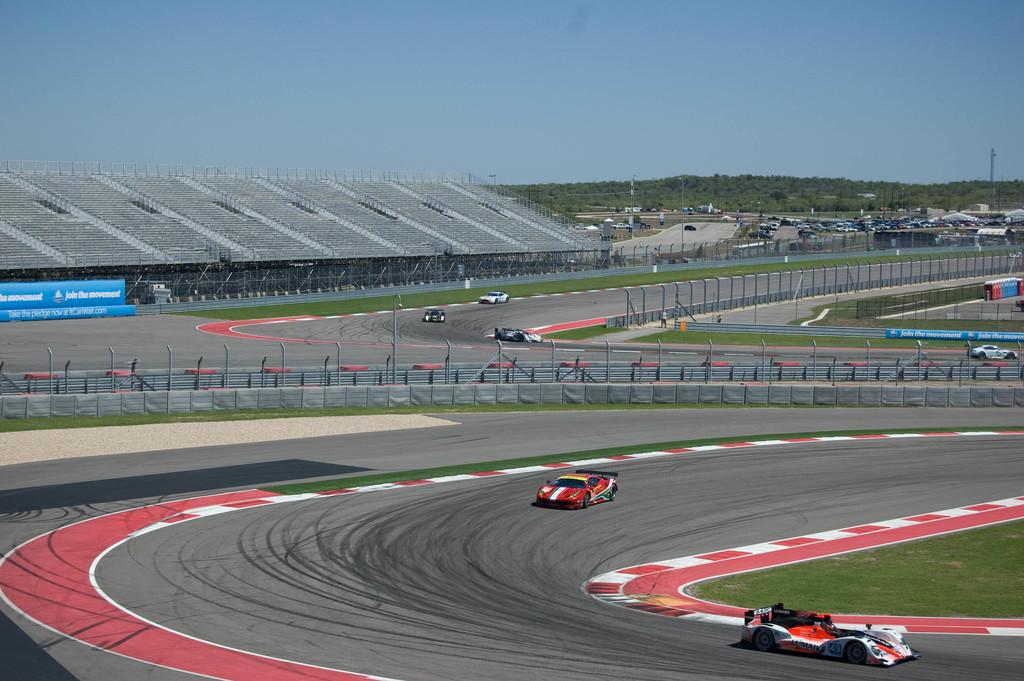What type of vehicle is racing in the image? There is an F1 car racing in the image. What else can be seen in the image besides the racing car? There are many parked cars in the image. What can be seen in the background of the image? Trees and the sky are visible in the background of the image. What type of glue is being used to hold the guitar in the image? There is no guitar present in the image, and therefore no glue or related activity can be observed. 